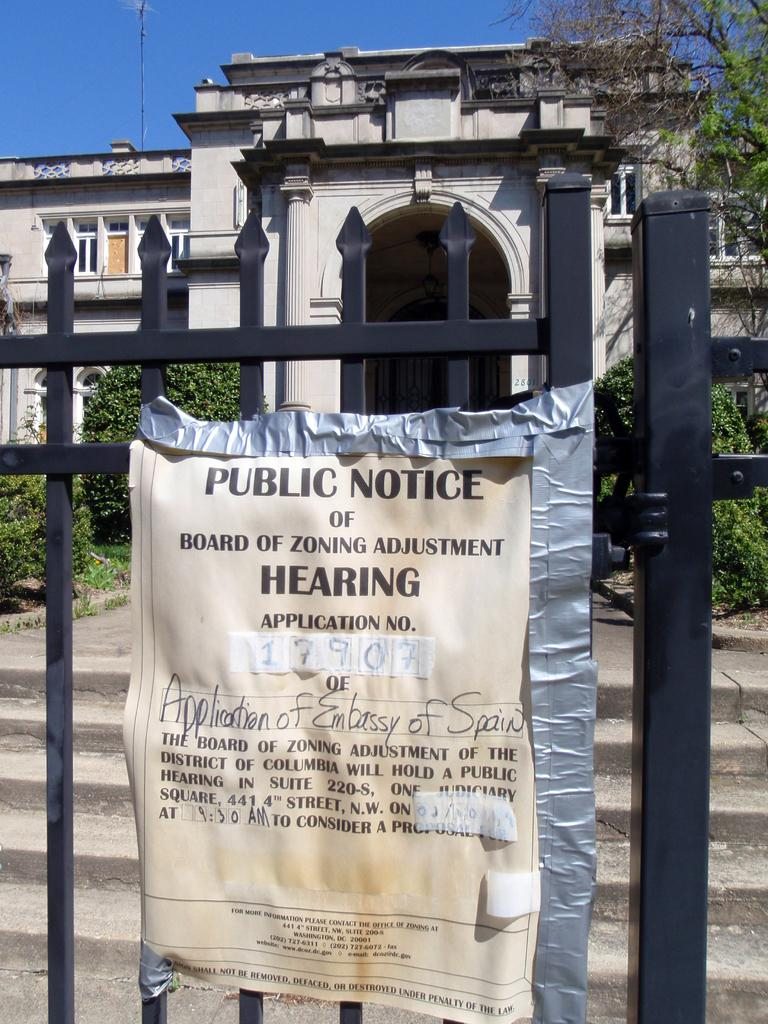What type of structure is visible in the image? There is a building in the image. What can be seen in the image besides the building? There are many plants and a tree in the image. Where is the notice located in the image? The notice is stuck on a gate in the image. What type of songs can be heard playing from the arch in the image? There is no arch present in the image, and therefore no songs can be heard playing from it. 